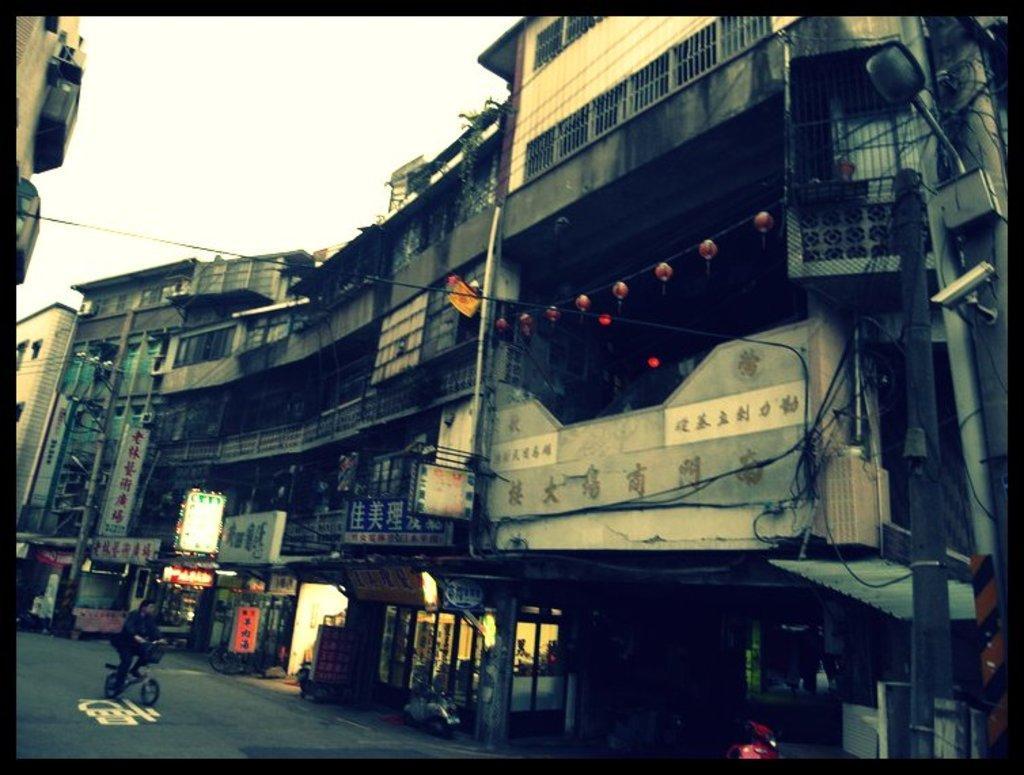Can you describe this image briefly? In the foreground of the image we can see some vehicles parked on the ground. One person is riding a bicycle. In the center of the image we can see group of buildings with windows , sign boards with text, railing. In the right side of the image we can see a light and CCTV camera on a pole. In the background, we can see the sky. 